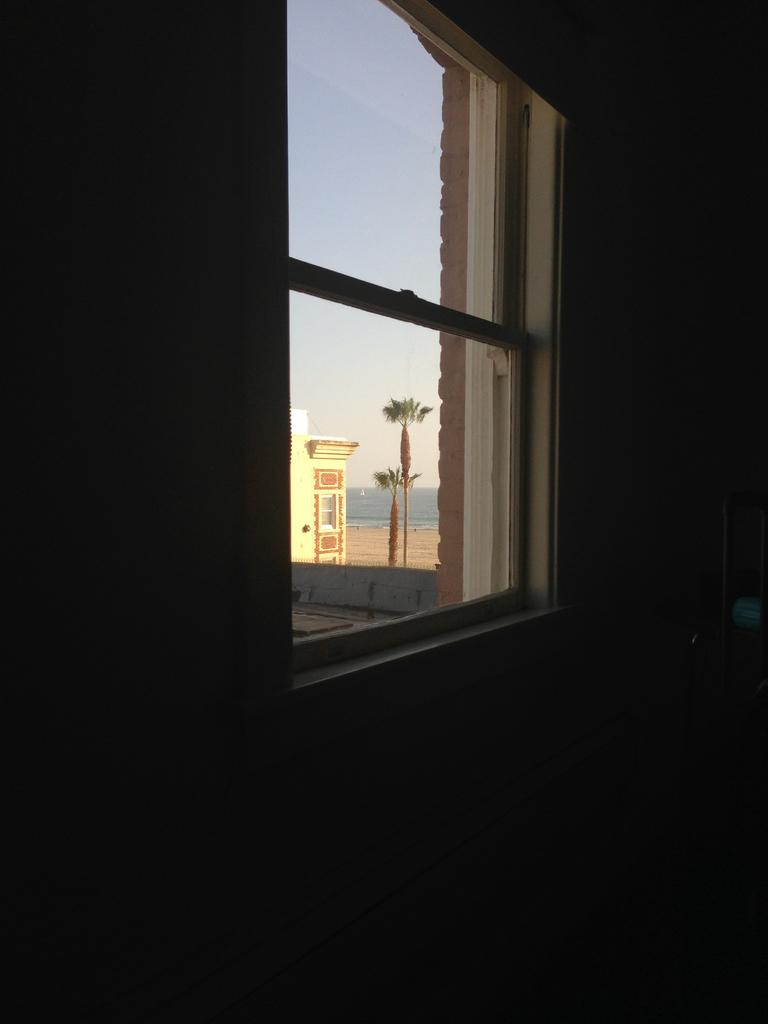What is present on the wall in the image? There is no information about the wall's contents in the provided facts. What can be seen through the window in the image? A building, trees, water, the sky, and sand are visible through the window in the image. How many different elements can be seen through the window? Five different elements can be seen through the window: a building, trees, water, the sky, and sand. What type of roof is visible on the building through the window? There is no information about the roof of the building visible through the window in the provided facts. Can you tell me the level of the window in the image? There is no information about the window's height or level in the provided facts. 